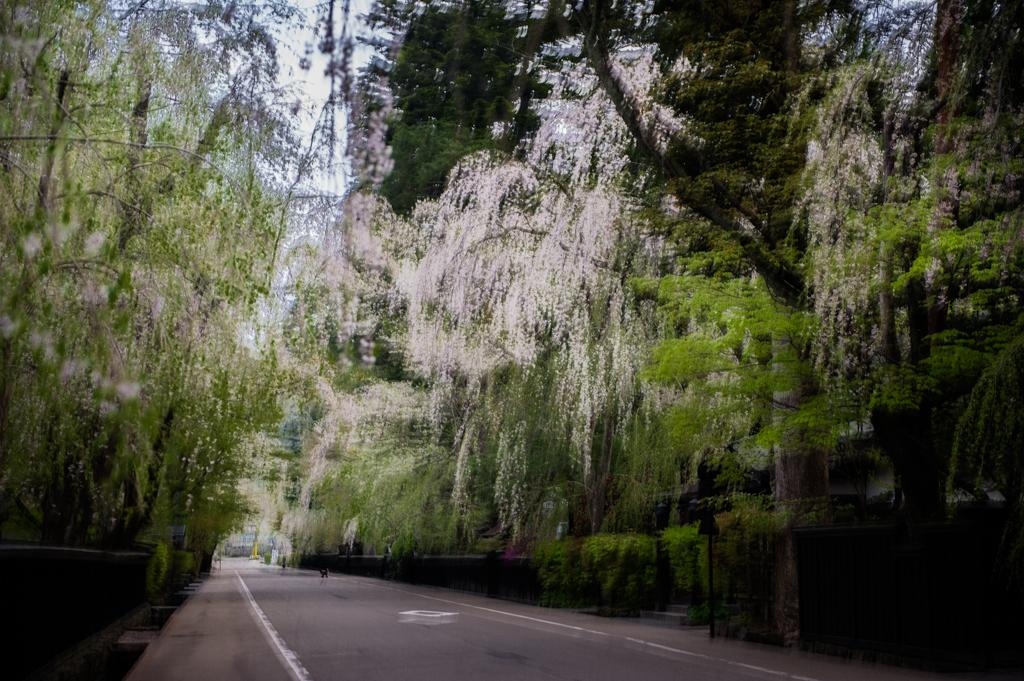What is located at the bottom of the image? There is a road at the bottom of the image. What can be seen in the background of the image? There are trees and the sky visible in the background of the image. What is on the right side of the image? There is a pole on the right side of the image. What is the condition of the moon in the image? There is no moon visible in the image; only the sky is visible in the background. What type of support is provided by the pole in the image? There is no indication of the pole's purpose or function in the image, so it is not possible to determine the type of support it provides. 